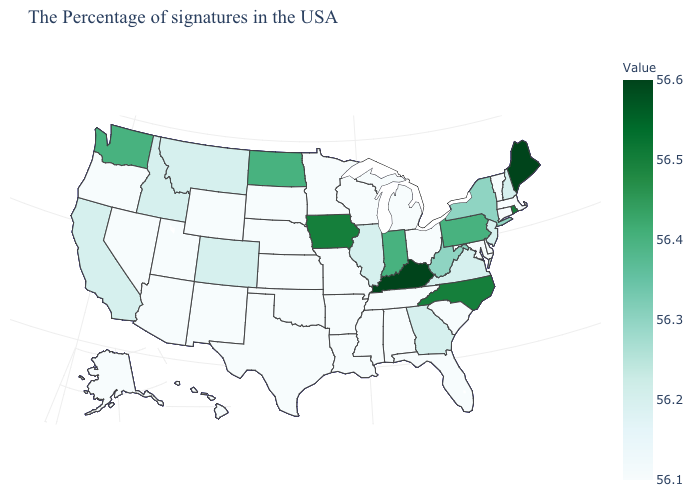Which states have the lowest value in the USA?
Short answer required. Massachusetts, Vermont, Connecticut, Delaware, Maryland, South Carolina, Ohio, Florida, Michigan, Alabama, Tennessee, Wisconsin, Mississippi, Louisiana, Missouri, Arkansas, Minnesota, Kansas, Nebraska, Oklahoma, Texas, South Dakota, Wyoming, New Mexico, Utah, Arizona, Nevada, Oregon, Alaska, Hawaii. Among the states that border Nevada , which have the highest value?
Write a very short answer. Idaho, California. Does Washington have the highest value in the West?
Answer briefly. Yes. Which states have the lowest value in the West?
Keep it brief. Wyoming, New Mexico, Utah, Arizona, Nevada, Oregon, Alaska, Hawaii. Which states have the lowest value in the South?
Concise answer only. Delaware, Maryland, South Carolina, Florida, Alabama, Tennessee, Mississippi, Louisiana, Arkansas, Oklahoma, Texas. Which states have the lowest value in the USA?
Concise answer only. Massachusetts, Vermont, Connecticut, Delaware, Maryland, South Carolina, Ohio, Florida, Michigan, Alabama, Tennessee, Wisconsin, Mississippi, Louisiana, Missouri, Arkansas, Minnesota, Kansas, Nebraska, Oklahoma, Texas, South Dakota, Wyoming, New Mexico, Utah, Arizona, Nevada, Oregon, Alaska, Hawaii. 